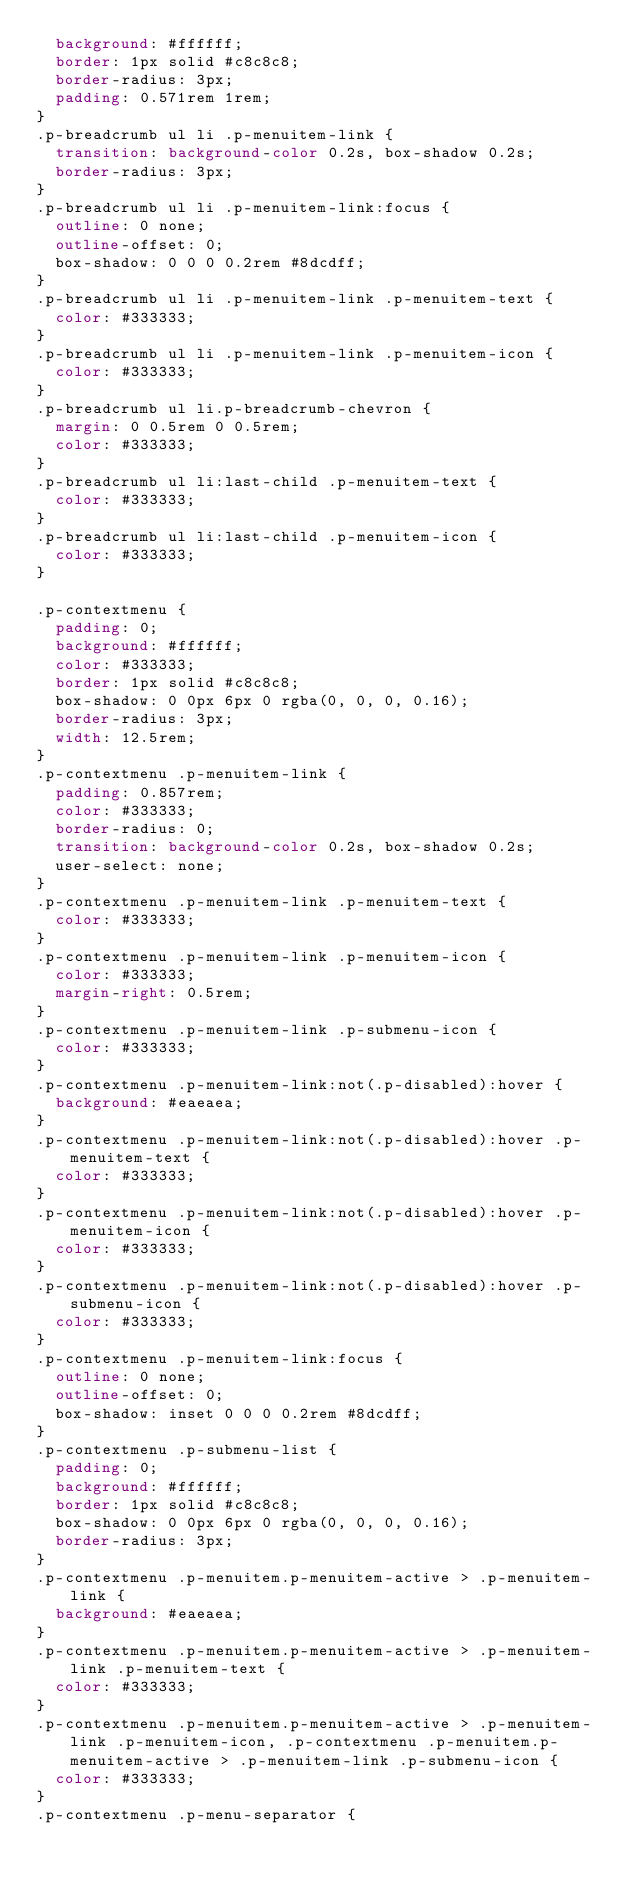<code> <loc_0><loc_0><loc_500><loc_500><_CSS_>  background: #ffffff;
  border: 1px solid #c8c8c8;
  border-radius: 3px;
  padding: 0.571rem 1rem;
}
.p-breadcrumb ul li .p-menuitem-link {
  transition: background-color 0.2s, box-shadow 0.2s;
  border-radius: 3px;
}
.p-breadcrumb ul li .p-menuitem-link:focus {
  outline: 0 none;
  outline-offset: 0;
  box-shadow: 0 0 0 0.2rem #8dcdff;
}
.p-breadcrumb ul li .p-menuitem-link .p-menuitem-text {
  color: #333333;
}
.p-breadcrumb ul li .p-menuitem-link .p-menuitem-icon {
  color: #333333;
}
.p-breadcrumb ul li.p-breadcrumb-chevron {
  margin: 0 0.5rem 0 0.5rem;
  color: #333333;
}
.p-breadcrumb ul li:last-child .p-menuitem-text {
  color: #333333;
}
.p-breadcrumb ul li:last-child .p-menuitem-icon {
  color: #333333;
}

.p-contextmenu {
  padding: 0;
  background: #ffffff;
  color: #333333;
  border: 1px solid #c8c8c8;
  box-shadow: 0 0px 6px 0 rgba(0, 0, 0, 0.16);
  border-radius: 3px;
  width: 12.5rem;
}
.p-contextmenu .p-menuitem-link {
  padding: 0.857rem;
  color: #333333;
  border-radius: 0;
  transition: background-color 0.2s, box-shadow 0.2s;
  user-select: none;
}
.p-contextmenu .p-menuitem-link .p-menuitem-text {
  color: #333333;
}
.p-contextmenu .p-menuitem-link .p-menuitem-icon {
  color: #333333;
  margin-right: 0.5rem;
}
.p-contextmenu .p-menuitem-link .p-submenu-icon {
  color: #333333;
}
.p-contextmenu .p-menuitem-link:not(.p-disabled):hover {
  background: #eaeaea;
}
.p-contextmenu .p-menuitem-link:not(.p-disabled):hover .p-menuitem-text {
  color: #333333;
}
.p-contextmenu .p-menuitem-link:not(.p-disabled):hover .p-menuitem-icon {
  color: #333333;
}
.p-contextmenu .p-menuitem-link:not(.p-disabled):hover .p-submenu-icon {
  color: #333333;
}
.p-contextmenu .p-menuitem-link:focus {
  outline: 0 none;
  outline-offset: 0;
  box-shadow: inset 0 0 0 0.2rem #8dcdff;
}
.p-contextmenu .p-submenu-list {
  padding: 0;
  background: #ffffff;
  border: 1px solid #c8c8c8;
  box-shadow: 0 0px 6px 0 rgba(0, 0, 0, 0.16);
  border-radius: 3px;
}
.p-contextmenu .p-menuitem.p-menuitem-active > .p-menuitem-link {
  background: #eaeaea;
}
.p-contextmenu .p-menuitem.p-menuitem-active > .p-menuitem-link .p-menuitem-text {
  color: #333333;
}
.p-contextmenu .p-menuitem.p-menuitem-active > .p-menuitem-link .p-menuitem-icon, .p-contextmenu .p-menuitem.p-menuitem-active > .p-menuitem-link .p-submenu-icon {
  color: #333333;
}
.p-contextmenu .p-menu-separator {</code> 